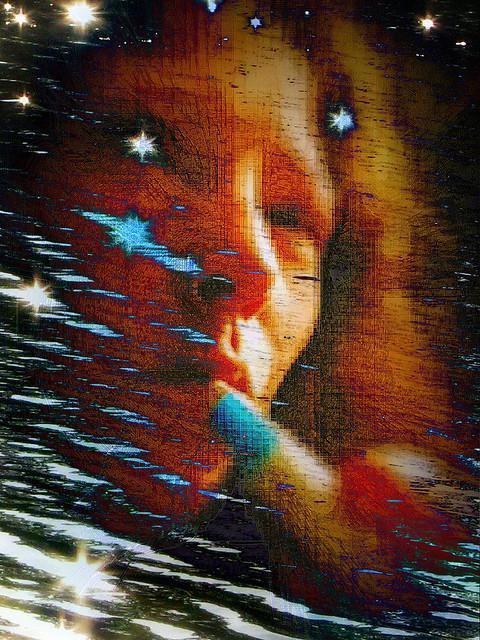How many bananas doe the guy have in his back pocket?
Give a very brief answer. 0. 